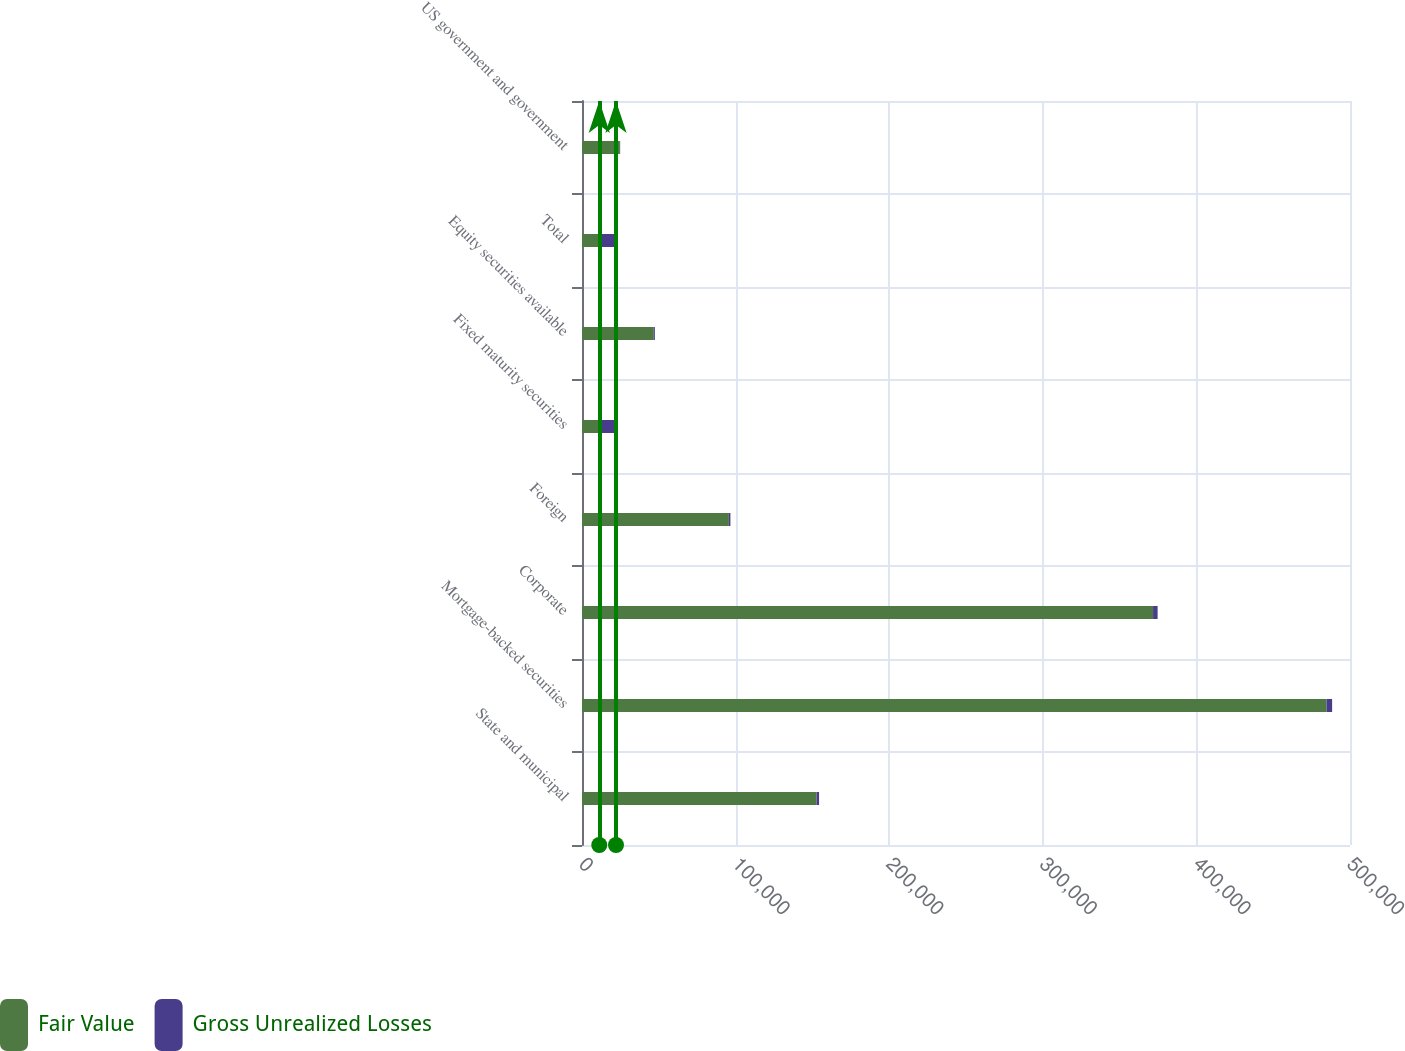Convert chart to OTSL. <chart><loc_0><loc_0><loc_500><loc_500><stacked_bar_chart><ecel><fcel>State and municipal<fcel>Mortgage-backed securities<fcel>Corporate<fcel>Foreign<fcel>Fixed maturity securities<fcel>Equity securities available<fcel>Total<fcel>US government and government<nl><fcel>Fair Value<fcel>152694<fcel>484731<fcel>371781<fcel>95623<fcel>11241.5<fcel>46725<fcel>11241.5<fcel>24668<nl><fcel>Gross Unrealized Losses<fcel>1639<fcel>3629<fcel>2964<fcel>996<fcel>10888<fcel>707<fcel>11595<fcel>169<nl></chart> 